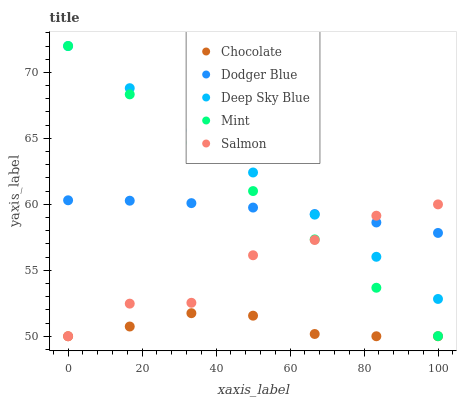Does Chocolate have the minimum area under the curve?
Answer yes or no. Yes. Does Deep Sky Blue have the maximum area under the curve?
Answer yes or no. Yes. Does Salmon have the minimum area under the curve?
Answer yes or no. No. Does Salmon have the maximum area under the curve?
Answer yes or no. No. Is Mint the smoothest?
Answer yes or no. Yes. Is Salmon the roughest?
Answer yes or no. Yes. Is Dodger Blue the smoothest?
Answer yes or no. No. Is Dodger Blue the roughest?
Answer yes or no. No. Does Salmon have the lowest value?
Answer yes or no. Yes. Does Dodger Blue have the lowest value?
Answer yes or no. No. Does Deep Sky Blue have the highest value?
Answer yes or no. Yes. Does Salmon have the highest value?
Answer yes or no. No. Is Chocolate less than Mint?
Answer yes or no. Yes. Is Deep Sky Blue greater than Chocolate?
Answer yes or no. Yes. Does Dodger Blue intersect Mint?
Answer yes or no. Yes. Is Dodger Blue less than Mint?
Answer yes or no. No. Is Dodger Blue greater than Mint?
Answer yes or no. No. Does Chocolate intersect Mint?
Answer yes or no. No. 